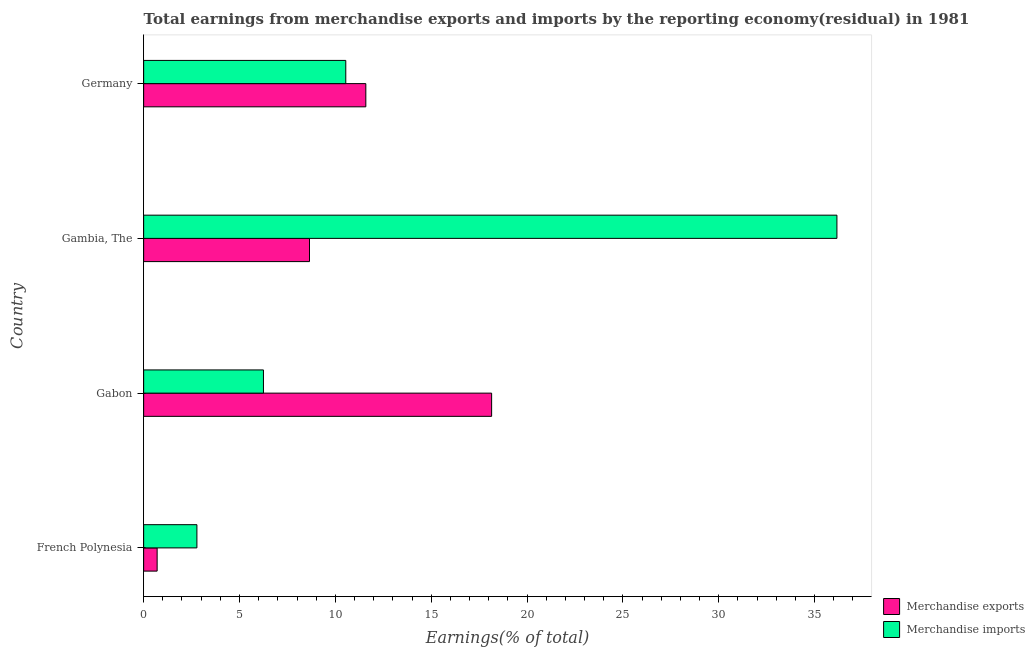How many different coloured bars are there?
Your answer should be compact. 2. How many bars are there on the 2nd tick from the top?
Ensure brevity in your answer.  2. What is the label of the 4th group of bars from the top?
Provide a succinct answer. French Polynesia. What is the earnings from merchandise imports in Gambia, The?
Provide a succinct answer. 36.17. Across all countries, what is the maximum earnings from merchandise imports?
Your answer should be compact. 36.17. Across all countries, what is the minimum earnings from merchandise imports?
Your answer should be compact. 2.78. In which country was the earnings from merchandise imports maximum?
Offer a very short reply. Gambia, The. In which country was the earnings from merchandise exports minimum?
Provide a short and direct response. French Polynesia. What is the total earnings from merchandise imports in the graph?
Offer a very short reply. 55.74. What is the difference between the earnings from merchandise imports in Gabon and that in Germany?
Make the answer very short. -4.3. What is the difference between the earnings from merchandise exports in Gambia, The and the earnings from merchandise imports in French Polynesia?
Give a very brief answer. 5.87. What is the average earnings from merchandise imports per country?
Offer a very short reply. 13.94. What is the difference between the earnings from merchandise exports and earnings from merchandise imports in Gambia, The?
Give a very brief answer. -27.52. What is the ratio of the earnings from merchandise exports in French Polynesia to that in Gambia, The?
Your response must be concise. 0.08. Is the earnings from merchandise imports in French Polynesia less than that in Gambia, The?
Provide a succinct answer. Yes. What is the difference between the highest and the second highest earnings from merchandise imports?
Your answer should be very brief. 25.62. What is the difference between the highest and the lowest earnings from merchandise imports?
Ensure brevity in your answer.  33.39. In how many countries, is the earnings from merchandise exports greater than the average earnings from merchandise exports taken over all countries?
Offer a terse response. 2. Are all the bars in the graph horizontal?
Your answer should be compact. Yes. How many countries are there in the graph?
Keep it short and to the point. 4. What is the difference between two consecutive major ticks on the X-axis?
Keep it short and to the point. 5. Does the graph contain grids?
Ensure brevity in your answer.  No. How many legend labels are there?
Give a very brief answer. 2. What is the title of the graph?
Make the answer very short. Total earnings from merchandise exports and imports by the reporting economy(residual) in 1981. Does "All education staff compensation" appear as one of the legend labels in the graph?
Offer a very short reply. No. What is the label or title of the X-axis?
Ensure brevity in your answer.  Earnings(% of total). What is the Earnings(% of total) in Merchandise exports in French Polynesia?
Provide a succinct answer. 0.7. What is the Earnings(% of total) in Merchandise imports in French Polynesia?
Your response must be concise. 2.78. What is the Earnings(% of total) of Merchandise exports in Gabon?
Give a very brief answer. 18.15. What is the Earnings(% of total) in Merchandise imports in Gabon?
Provide a short and direct response. 6.25. What is the Earnings(% of total) of Merchandise exports in Gambia, The?
Offer a very short reply. 8.65. What is the Earnings(% of total) in Merchandise imports in Gambia, The?
Offer a terse response. 36.17. What is the Earnings(% of total) of Merchandise exports in Germany?
Offer a terse response. 11.59. What is the Earnings(% of total) in Merchandise imports in Germany?
Ensure brevity in your answer.  10.55. Across all countries, what is the maximum Earnings(% of total) in Merchandise exports?
Keep it short and to the point. 18.15. Across all countries, what is the maximum Earnings(% of total) of Merchandise imports?
Offer a terse response. 36.17. Across all countries, what is the minimum Earnings(% of total) in Merchandise exports?
Offer a terse response. 0.7. Across all countries, what is the minimum Earnings(% of total) in Merchandise imports?
Offer a terse response. 2.78. What is the total Earnings(% of total) in Merchandise exports in the graph?
Offer a very short reply. 39.1. What is the total Earnings(% of total) of Merchandise imports in the graph?
Ensure brevity in your answer.  55.74. What is the difference between the Earnings(% of total) in Merchandise exports in French Polynesia and that in Gabon?
Provide a succinct answer. -17.45. What is the difference between the Earnings(% of total) of Merchandise imports in French Polynesia and that in Gabon?
Provide a short and direct response. -3.47. What is the difference between the Earnings(% of total) of Merchandise exports in French Polynesia and that in Gambia, The?
Give a very brief answer. -7.95. What is the difference between the Earnings(% of total) in Merchandise imports in French Polynesia and that in Gambia, The?
Offer a very short reply. -33.39. What is the difference between the Earnings(% of total) in Merchandise exports in French Polynesia and that in Germany?
Offer a very short reply. -10.89. What is the difference between the Earnings(% of total) in Merchandise imports in French Polynesia and that in Germany?
Offer a terse response. -7.77. What is the difference between the Earnings(% of total) of Merchandise exports in Gabon and that in Gambia, The?
Give a very brief answer. 9.5. What is the difference between the Earnings(% of total) in Merchandise imports in Gabon and that in Gambia, The?
Offer a very short reply. -29.92. What is the difference between the Earnings(% of total) in Merchandise exports in Gabon and that in Germany?
Give a very brief answer. 6.56. What is the difference between the Earnings(% of total) of Merchandise imports in Gabon and that in Germany?
Provide a short and direct response. -4.3. What is the difference between the Earnings(% of total) of Merchandise exports in Gambia, The and that in Germany?
Provide a succinct answer. -2.94. What is the difference between the Earnings(% of total) of Merchandise imports in Gambia, The and that in Germany?
Provide a succinct answer. 25.62. What is the difference between the Earnings(% of total) of Merchandise exports in French Polynesia and the Earnings(% of total) of Merchandise imports in Gabon?
Keep it short and to the point. -5.55. What is the difference between the Earnings(% of total) of Merchandise exports in French Polynesia and the Earnings(% of total) of Merchandise imports in Gambia, The?
Your answer should be very brief. -35.46. What is the difference between the Earnings(% of total) in Merchandise exports in French Polynesia and the Earnings(% of total) in Merchandise imports in Germany?
Your answer should be very brief. -9.84. What is the difference between the Earnings(% of total) of Merchandise exports in Gabon and the Earnings(% of total) of Merchandise imports in Gambia, The?
Offer a terse response. -18.01. What is the difference between the Earnings(% of total) in Merchandise exports in Gabon and the Earnings(% of total) in Merchandise imports in Germany?
Ensure brevity in your answer.  7.61. What is the difference between the Earnings(% of total) in Merchandise exports in Gambia, The and the Earnings(% of total) in Merchandise imports in Germany?
Your answer should be compact. -1.89. What is the average Earnings(% of total) of Merchandise exports per country?
Keep it short and to the point. 9.78. What is the average Earnings(% of total) of Merchandise imports per country?
Make the answer very short. 13.94. What is the difference between the Earnings(% of total) in Merchandise exports and Earnings(% of total) in Merchandise imports in French Polynesia?
Your response must be concise. -2.07. What is the difference between the Earnings(% of total) of Merchandise exports and Earnings(% of total) of Merchandise imports in Gabon?
Offer a terse response. 11.9. What is the difference between the Earnings(% of total) of Merchandise exports and Earnings(% of total) of Merchandise imports in Gambia, The?
Provide a short and direct response. -27.52. What is the difference between the Earnings(% of total) of Merchandise exports and Earnings(% of total) of Merchandise imports in Germany?
Your answer should be compact. 1.05. What is the ratio of the Earnings(% of total) in Merchandise exports in French Polynesia to that in Gabon?
Give a very brief answer. 0.04. What is the ratio of the Earnings(% of total) of Merchandise imports in French Polynesia to that in Gabon?
Your response must be concise. 0.44. What is the ratio of the Earnings(% of total) in Merchandise exports in French Polynesia to that in Gambia, The?
Offer a very short reply. 0.08. What is the ratio of the Earnings(% of total) of Merchandise imports in French Polynesia to that in Gambia, The?
Your answer should be compact. 0.08. What is the ratio of the Earnings(% of total) in Merchandise exports in French Polynesia to that in Germany?
Make the answer very short. 0.06. What is the ratio of the Earnings(% of total) of Merchandise imports in French Polynesia to that in Germany?
Make the answer very short. 0.26. What is the ratio of the Earnings(% of total) in Merchandise exports in Gabon to that in Gambia, The?
Provide a succinct answer. 2.1. What is the ratio of the Earnings(% of total) of Merchandise imports in Gabon to that in Gambia, The?
Ensure brevity in your answer.  0.17. What is the ratio of the Earnings(% of total) in Merchandise exports in Gabon to that in Germany?
Give a very brief answer. 1.57. What is the ratio of the Earnings(% of total) in Merchandise imports in Gabon to that in Germany?
Provide a succinct answer. 0.59. What is the ratio of the Earnings(% of total) in Merchandise exports in Gambia, The to that in Germany?
Keep it short and to the point. 0.75. What is the ratio of the Earnings(% of total) in Merchandise imports in Gambia, The to that in Germany?
Keep it short and to the point. 3.43. What is the difference between the highest and the second highest Earnings(% of total) of Merchandise exports?
Make the answer very short. 6.56. What is the difference between the highest and the second highest Earnings(% of total) in Merchandise imports?
Offer a very short reply. 25.62. What is the difference between the highest and the lowest Earnings(% of total) in Merchandise exports?
Make the answer very short. 17.45. What is the difference between the highest and the lowest Earnings(% of total) of Merchandise imports?
Provide a short and direct response. 33.39. 